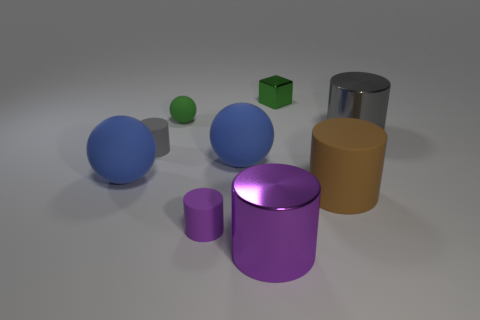How are the objects arranged in the space? The objects are casually scattered with no apparent pattern, giving a sense of randomness to their placement.  What could this image be used to represent? This image can represent concepts like diversity, complexity, or the study of geometry and spatial relationships. 